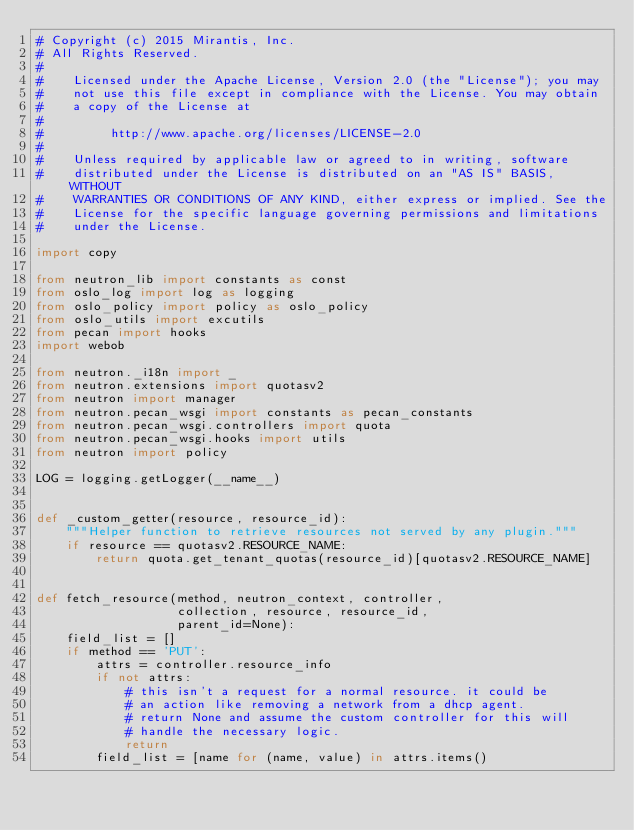<code> <loc_0><loc_0><loc_500><loc_500><_Python_># Copyright (c) 2015 Mirantis, Inc.
# All Rights Reserved.
#
#    Licensed under the Apache License, Version 2.0 (the "License"); you may
#    not use this file except in compliance with the License. You may obtain
#    a copy of the License at
#
#         http://www.apache.org/licenses/LICENSE-2.0
#
#    Unless required by applicable law or agreed to in writing, software
#    distributed under the License is distributed on an "AS IS" BASIS, WITHOUT
#    WARRANTIES OR CONDITIONS OF ANY KIND, either express or implied. See the
#    License for the specific language governing permissions and limitations
#    under the License.

import copy

from neutron_lib import constants as const
from oslo_log import log as logging
from oslo_policy import policy as oslo_policy
from oslo_utils import excutils
from pecan import hooks
import webob

from neutron._i18n import _
from neutron.extensions import quotasv2
from neutron import manager
from neutron.pecan_wsgi import constants as pecan_constants
from neutron.pecan_wsgi.controllers import quota
from neutron.pecan_wsgi.hooks import utils
from neutron import policy

LOG = logging.getLogger(__name__)


def _custom_getter(resource, resource_id):
    """Helper function to retrieve resources not served by any plugin."""
    if resource == quotasv2.RESOURCE_NAME:
        return quota.get_tenant_quotas(resource_id)[quotasv2.RESOURCE_NAME]


def fetch_resource(method, neutron_context, controller,
                   collection, resource, resource_id,
                   parent_id=None):
    field_list = []
    if method == 'PUT':
        attrs = controller.resource_info
        if not attrs:
            # this isn't a request for a normal resource. it could be
            # an action like removing a network from a dhcp agent.
            # return None and assume the custom controller for this will
            # handle the necessary logic.
            return
        field_list = [name for (name, value) in attrs.items()</code> 